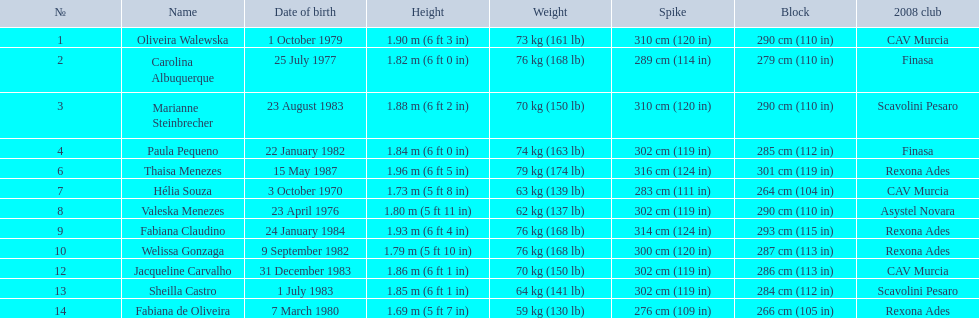What are the full names? Oliveira Walewska, Carolina Albuquerque, Marianne Steinbrecher, Paula Pequeno, Thaisa Menezes, Hélia Souza, Valeska Menezes, Fabiana Claudino, Welissa Gonzaga, Jacqueline Carvalho, Sheilla Castro, Fabiana de Oliveira. What are their corresponding weights? 73 kg (161 lb), 76 kg (168 lb), 70 kg (150 lb), 74 kg (163 lb), 79 kg (174 lb), 63 kg (139 lb), 62 kg (137 lb), 76 kg (168 lb), 76 kg (168 lb), 70 kg (150 lb), 64 kg (141 lb), 59 kg (130 lb). What was the weight of helia souza, fabiana de oliveira, and sheilla castro? Hélia Souza, Sheilla Castro, Fabiana de Oliveira. And who had the greatest weight? Sheilla Castro. 